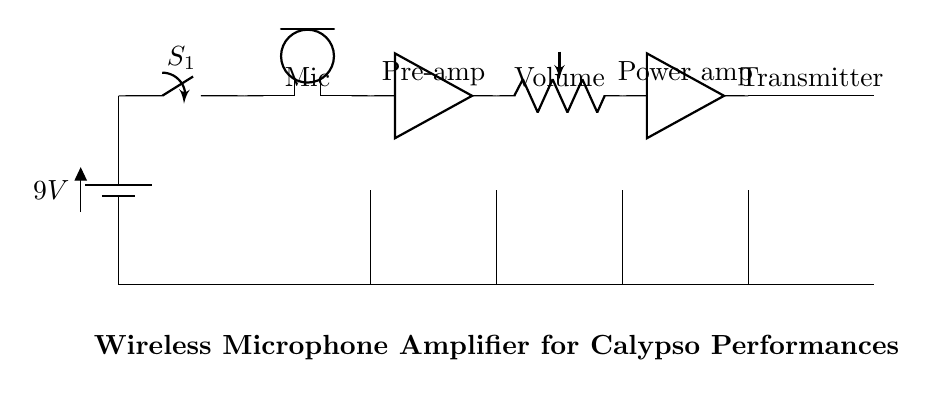What is the power source voltage for this circuit? The voltage is labeled as 9V on the battery component in the diagram, indicating the potential it provides to the circuit.
Answer: 9V What components are connected in series before the power amplifier? From the battery, the components connected in series before the power amplifier are the switch, microphone, pre-amplifier, and volume control. They are linked sequentially, indicating the flow of current from one to the next.
Answer: Switch, Microphone, Pre-amp, Volume How many amplification stages are present in this circuit? The circuit contains two amplification stages: one pre-amplifier and one power amplifier, according to the labeled components.
Answer: Two What function does the volume control serve in this circuit? The volume control potentiometer adjusts the amplitude of the audio signal before it reaches the power amplifier stage, allowing the user to manipulate the sound level output.
Answer: Signal adjustment What does the wireless transmitter connect to? The wireless transmitter connects to the power amplifier, allowing the amplified audio signal to be transmitted wirelessly to speakers or audio systems.
Answer: Power amplifier What type of circuit is represented in the diagram? The diagram represents a wireless microphone amplifier circuit specifically designed for calypso performances, highlighted by the arrangement of components suitable for interactive audience engagement.
Answer: Wireless microphone amplifier 